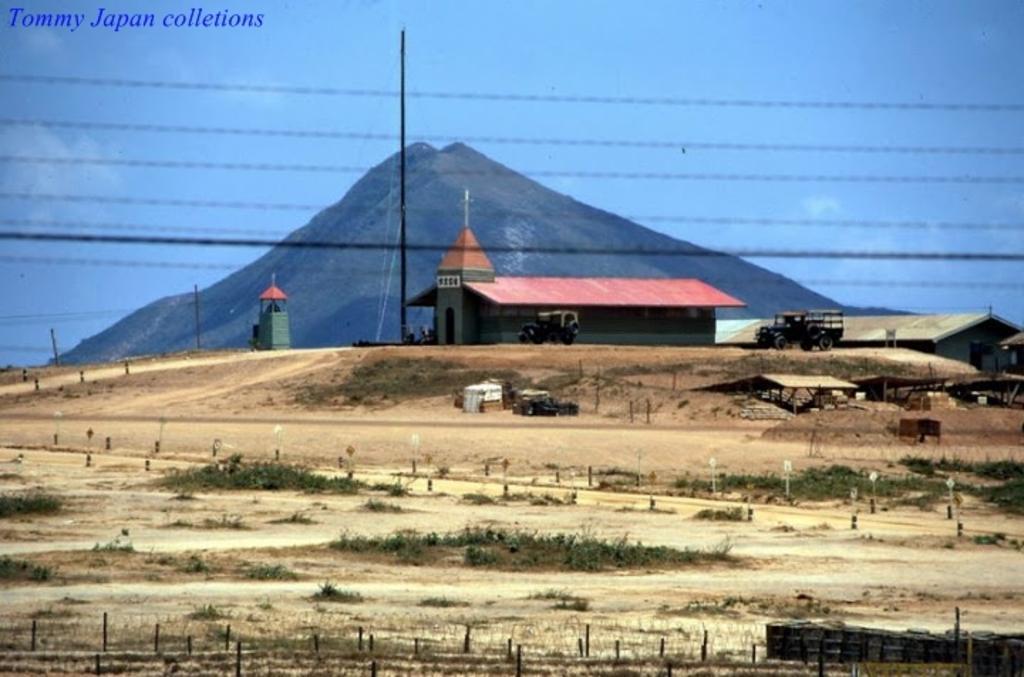Please provide a concise description of this image. This picture is clicked outside the city. At the bottom of the picture, we see grass and poles. In the middle of the picture, we see two jeeps parked on the road and we even see a church, house and shed. In the background, we see a hill and at the top of the picture, we see the sky. 